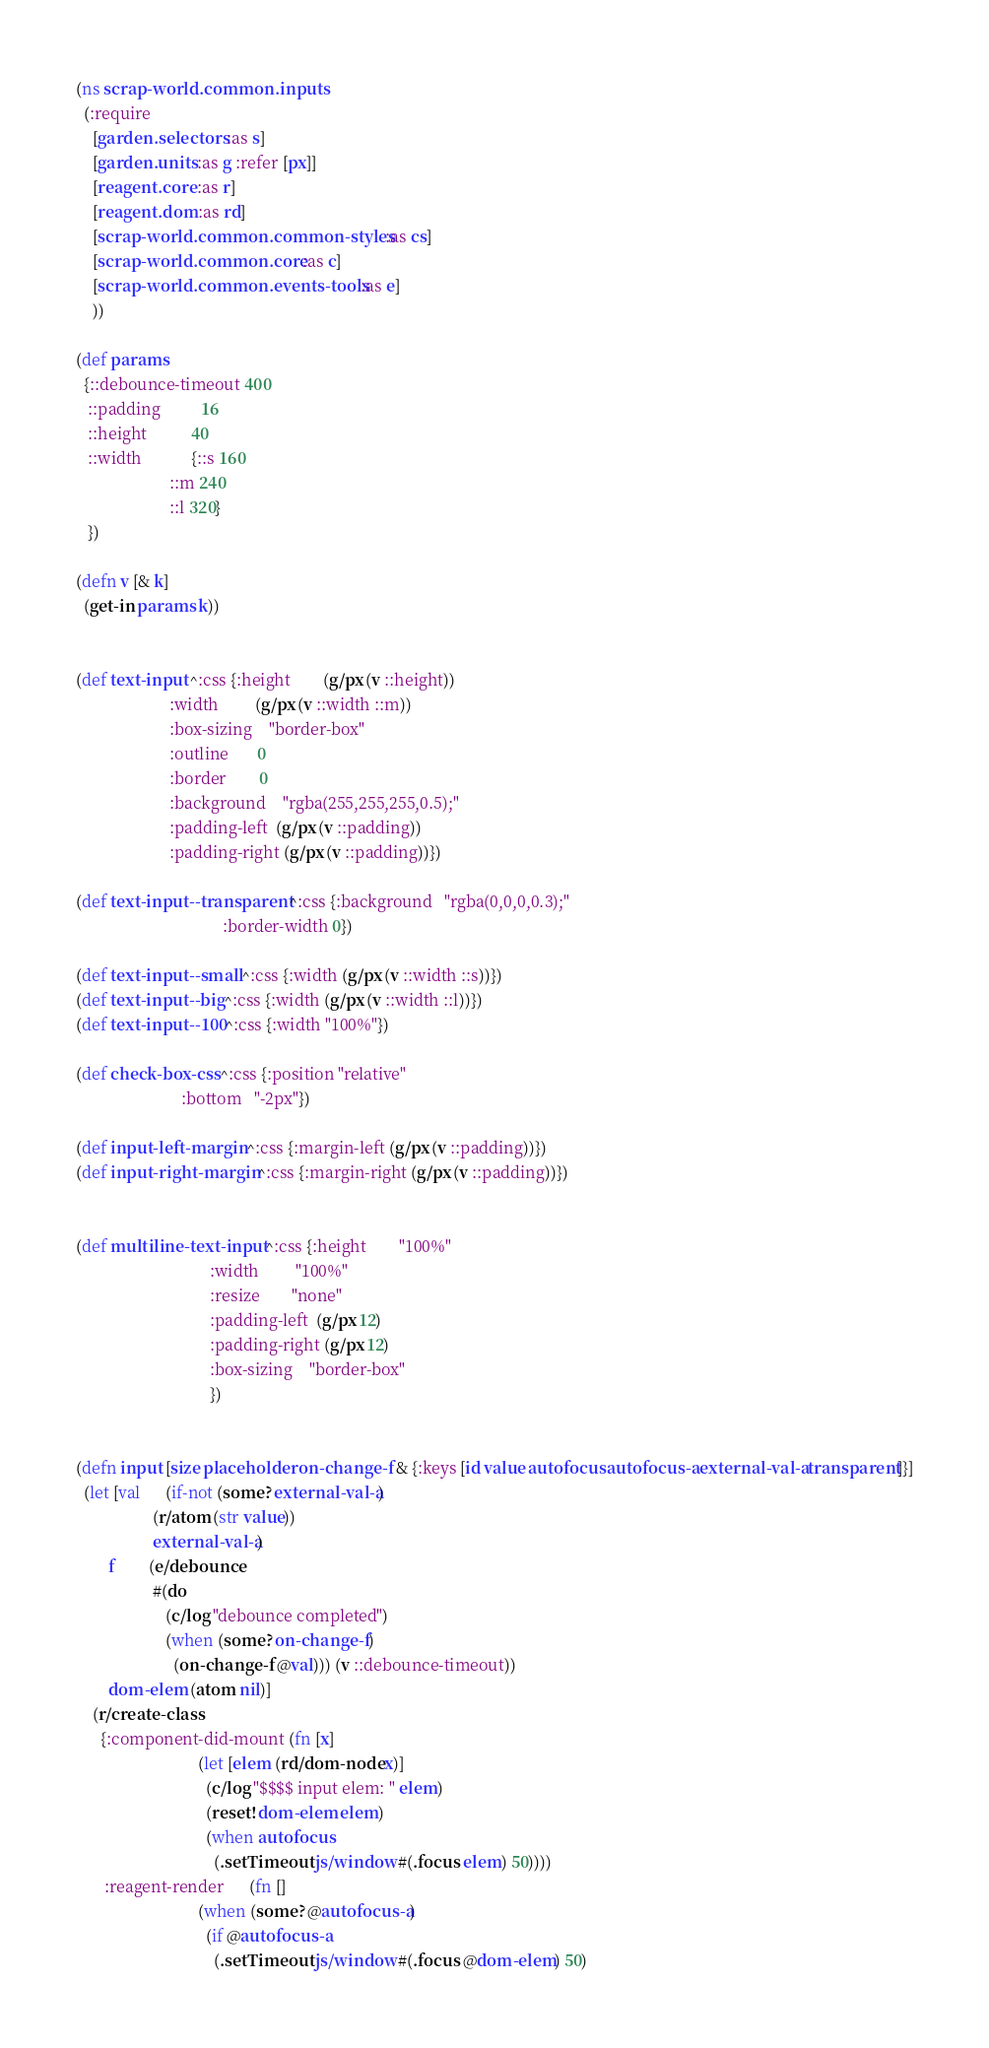Convert code to text. <code><loc_0><loc_0><loc_500><loc_500><_Clojure_>(ns scrap-world.common.inputs
  (:require
    [garden.selectors :as s]
    [garden.units :as g :refer [px]]
    [reagent.core :as r]
    [reagent.dom :as rd]
    [scrap-world.common.common-styles :as cs]
    [scrap-world.common.core :as c]
    [scrap-world.common.events-tools :as e]
    ))

(def params
  {::debounce-timeout 400
   ::padding          16
   ::height           40
   ::width            {::s 160
                       ::m 240
                       ::l 320}
   })

(defn v [& k]
  (get-in params k))


(def text-input ^:css {:height        (g/px (v ::height))
                       :width         (g/px (v ::width ::m))
                       :box-sizing    "border-box"
                       :outline       0
                       :border        0
                       :background    "rgba(255,255,255,0.5);"
                       :padding-left  (g/px (v ::padding))
                       :padding-right (g/px (v ::padding))})

(def text-input--transparent ^:css {:background   "rgba(0,0,0,0.3);"
                                    :border-width 0})

(def text-input--small ^:css {:width (g/px (v ::width ::s))})
(def text-input--big ^:css {:width (g/px (v ::width ::l))})
(def text-input--100 ^:css {:width "100%"})

(def check-box-css ^:css {:position "relative"
                          :bottom   "-2px"})

(def input-left-margin ^:css {:margin-left (g/px (v ::padding))})
(def input-right-margin ^:css {:margin-right (g/px (v ::padding))})


(def multiline-text-input ^:css {:height        "100%"
                                 :width         "100%"
                                 :resize        "none"
                                 :padding-left  (g/px 12)
                                 :padding-right (g/px 12)
                                 :box-sizing    "border-box"
                                 })


(defn input [size placeholder on-change-f & {:keys [id value autofocus autofocus-a external-val-a transparent]}]
  (let [val      (if-not (some? external-val-a)
                   (r/atom (str value))
                   external-val-a)
        f        (e/debounce
                   #(do
                      (c/log "debounce completed")
                      (when (some? on-change-f)
                        (on-change-f @val))) (v ::debounce-timeout))
        dom-elem (atom nil)]
    (r/create-class
      {:component-did-mount (fn [x]
                              (let [elem (rd/dom-node x)]
                                (c/log "$$$$ input elem: " elem)
                                (reset! dom-elem elem)
                                (when autofocus
                                  (.setTimeout js/window #(.focus elem) 50))))
       :reagent-render      (fn []
                              (when (some? @autofocus-a)
                                (if @autofocus-a
                                  (.setTimeout js/window #(.focus @dom-elem) 50)</code> 